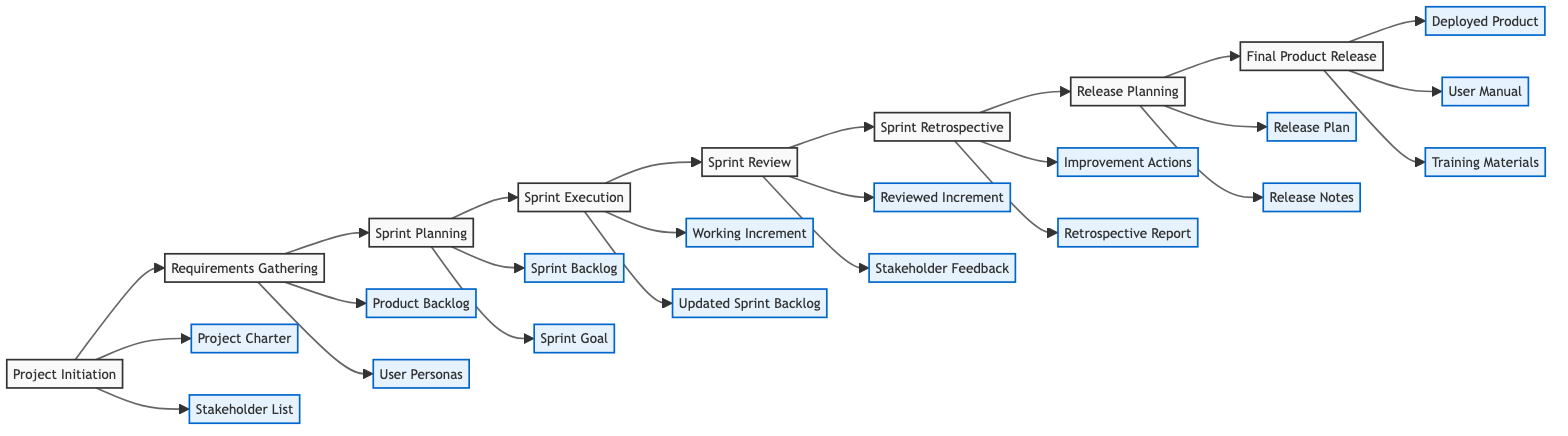What is the first step in the agile software development process? The first step in the diagram is labeled "Project Initiation", indicating the starting point of the agile software development process.
Answer: Project Initiation What output is generated after the "Sprint Execution"? The outputs listed after the "Sprint Execution" step are "Working Increment" and "Updated Sprint Backlog", which are produced as a result of this phase.
Answer: Working Increment, Updated Sprint Backlog How many steps are there in the agile software development flowchart? By counting the nodes in the diagram, there are a total of 8 steps represented, starting from "Project Initiation" to "Final Product Release".
Answer: 8 What is the relationship between "Release Planning" and "Final Product Release"? The "Release Planning" step directly leads to the "Final Product Release," indicating that the content and plans determined during the release planning phase are applied in the resulting product release.
Answer: Direct sequence What is the output of the "Sprint Review"? The output of the "Sprint Review" is listed as "Reviewed Increment" and "Stakeholder Feedback", reflecting what is achieved during this step.
Answer: Reviewed Increment, Stakeholder Feedback Which step comes before "Sprint Retrospective"? The step that precedes "Sprint Retrospective" is "Sprint Review", showing the order in which the processes occur in the agile methodology.
Answer: Sprint Review What is the final output generated in the process? The final outputs listed at the end of the process in the "Final Product Release" step are "Deployed Product," "User Manual," and "Training Materials," indicating what is delivered at the end.
Answer: Deployed Product, User Manual, Training Materials Which output is generated after "Requirements Gathering"? The outputs produced after the "Requirements Gathering" step are "Product Backlog" and "User Personas", representing the key artifacts resulting from gathering requirements.
Answer: Product Backlog, User Personas What outputs are created during "Sprint Planning"? The "Sprint Planning" step generates two specific outputs: "Sprint Backlog" and "Sprint Goal", which are crucial for guiding the work in the sprint cycle.
Answer: Sprint Backlog, Sprint Goal 